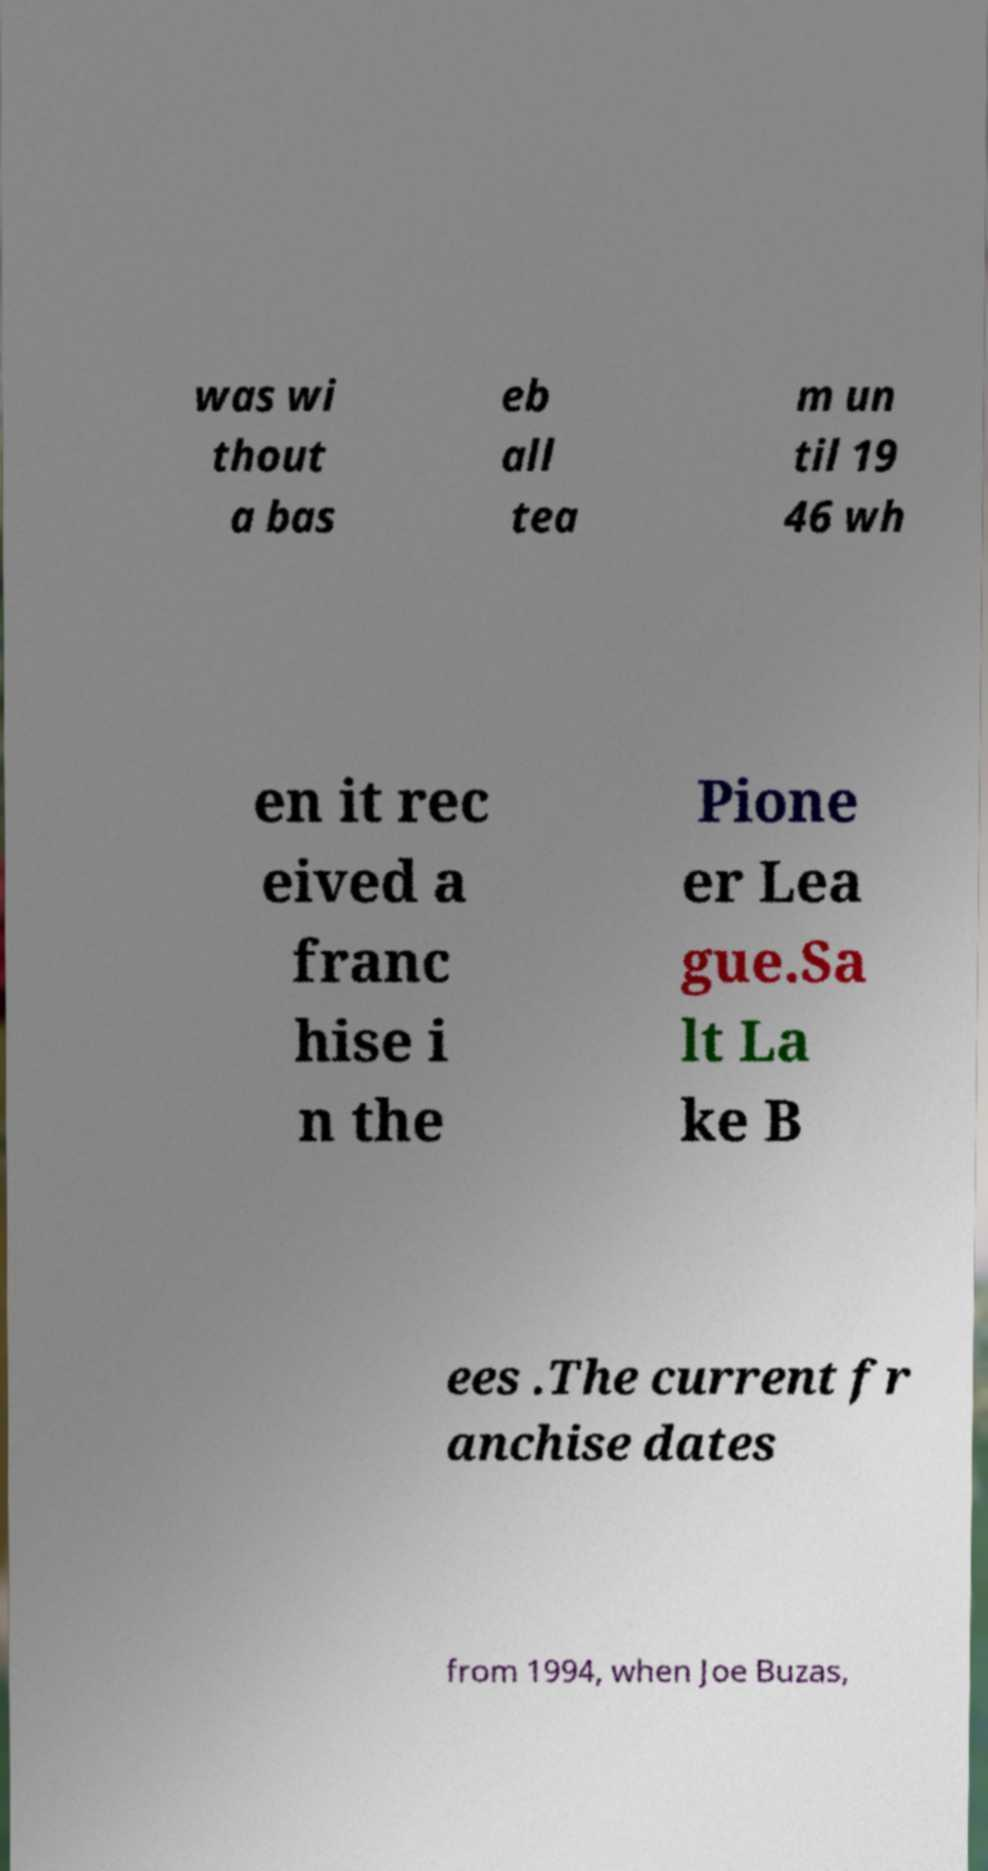Could you assist in decoding the text presented in this image and type it out clearly? was wi thout a bas eb all tea m un til 19 46 wh en it rec eived a franc hise i n the Pione er Lea gue.Sa lt La ke B ees .The current fr anchise dates from 1994, when Joe Buzas, 